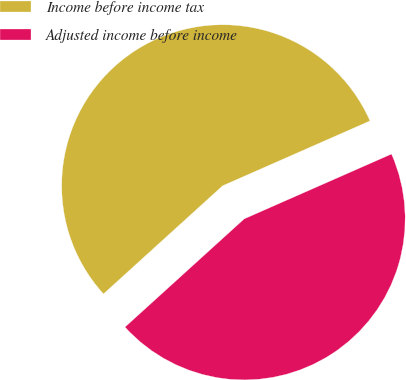Convert chart to OTSL. <chart><loc_0><loc_0><loc_500><loc_500><pie_chart><fcel>Income before income tax<fcel>Adjusted income before income<nl><fcel>55.13%<fcel>44.87%<nl></chart> 